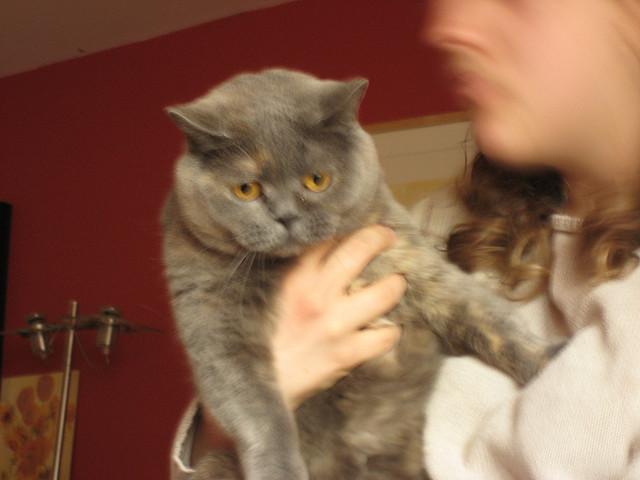Is the cat pretty?
Give a very brief answer. Yes. What part of the woman's body is the cat touching over her clothes?
Concise answer only. Chest. What color is the cat?
Write a very short answer. Gray. On this animal, what is NOT black?
Answer briefly. Fur. What is the cats breed?
Write a very short answer. Tabby. Is the cat standing or sitting?
Quick response, please. Standing. What thought is likely going through this cat's mind?
Short answer required. Put me down. What cat is here?
Answer briefly. Gray. Does this cat have stripes?
Concise answer only. No. Is the person in the photo moving?
Keep it brief. Yes. What color are the cat's eyes?
Quick response, please. Yellow. 